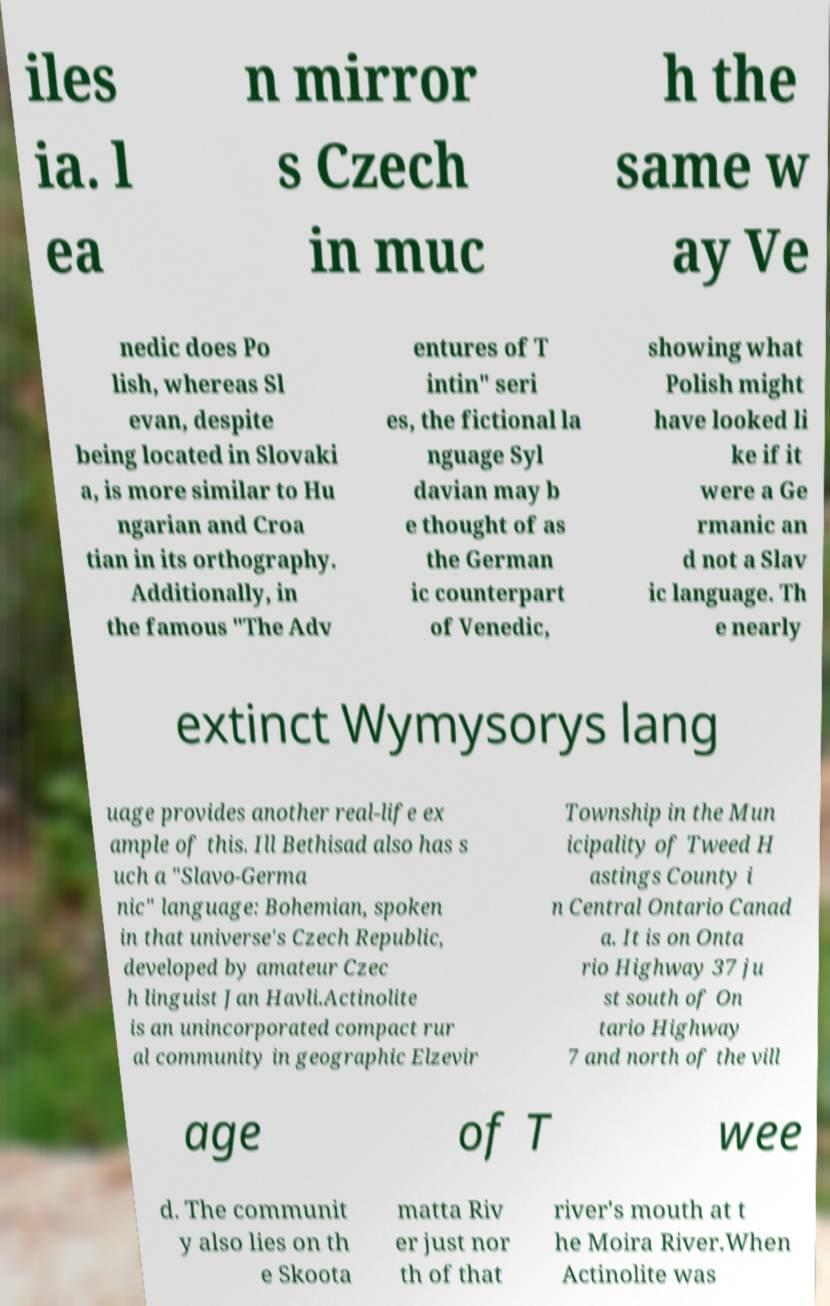Please read and relay the text visible in this image. What does it say? iles ia. l ea n mirror s Czech in muc h the same w ay Ve nedic does Po lish, whereas Sl evan, despite being located in Slovaki a, is more similar to Hu ngarian and Croa tian in its orthography. Additionally, in the famous "The Adv entures of T intin" seri es, the fictional la nguage Syl davian may b e thought of as the German ic counterpart of Venedic, showing what Polish might have looked li ke if it were a Ge rmanic an d not a Slav ic language. Th e nearly extinct Wymysorys lang uage provides another real-life ex ample of this. Ill Bethisad also has s uch a "Slavo-Germa nic" language: Bohemian, spoken in that universe's Czech Republic, developed by amateur Czec h linguist Jan Havli.Actinolite is an unincorporated compact rur al community in geographic Elzevir Township in the Mun icipality of Tweed H astings County i n Central Ontario Canad a. It is on Onta rio Highway 37 ju st south of On tario Highway 7 and north of the vill age of T wee d. The communit y also lies on th e Skoota matta Riv er just nor th of that river's mouth at t he Moira River.When Actinolite was 